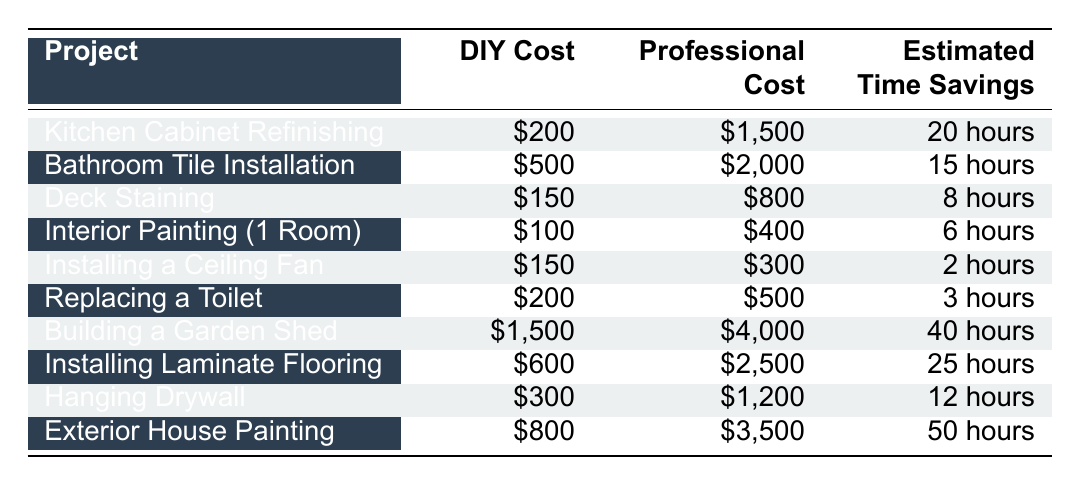What is the DIY cost for Kitchen Cabinet Refinishing? The table lists the DIY cost for Kitchen Cabinet Refinishing as $200.
Answer: $200 What is the cost difference between Professional Tile Installation and DIY Tile Installation? The professional cost for Bathroom Tile Installation is $2,000, and the DIY cost is $500. The difference is $2,000 - $500 = $1,500.
Answer: $1,500 Is the DIY cost for installing a ceiling fan less than the professional cost? The DIY cost for Installing a Ceiling Fan is $150, while the professional cost is $300. Since $150 is less than $300, the statement is true.
Answer: Yes Which project yields the highest estimated time savings? The highest estimated time savings can be found by comparing the "Estimated Time Savings" column. Exterior House Painting has the highest at 50 hours.
Answer: 50 hours If I choose to hire a professional for both Kitchen Cabinet Refinishing and Interior Painting, what would be the total cost? The professional costs for Kitchen Cabinet Refinishing and Interior Painting are $1,500 and $400, respectively. The total cost is $1,500 + $400 = $1,900.
Answer: $1,900 Is it cheaper to perform Deck Staining DIY than to hire a professional? The DIY cost for Deck Staining is $150, which is less than the professional cost of $800. Therefore, it is cheaper to do it yourself.
Answer: Yes What is the average DIY cost of all projects listed in the table? The DIY costs are $200, $500, $150, $100, $150, $200, $1,500, $600, $300, and $800. The sum is $3,650, and there are 10 projects, so the average is $3,650 / 10 = $365.
Answer: $365 Which project has the lowest DIY cost? Reviewing the DIY costs in the table, Interior Painting (1 Room) has the lowest cost at $100.
Answer: $100 How much time would I save if I choose to DIY instead of hiring a professional for Bathroom Tile Installation? The estimated time savings for Bathroom Tile Installation is 15 hours if DIY is chosen.
Answer: 15 hours 